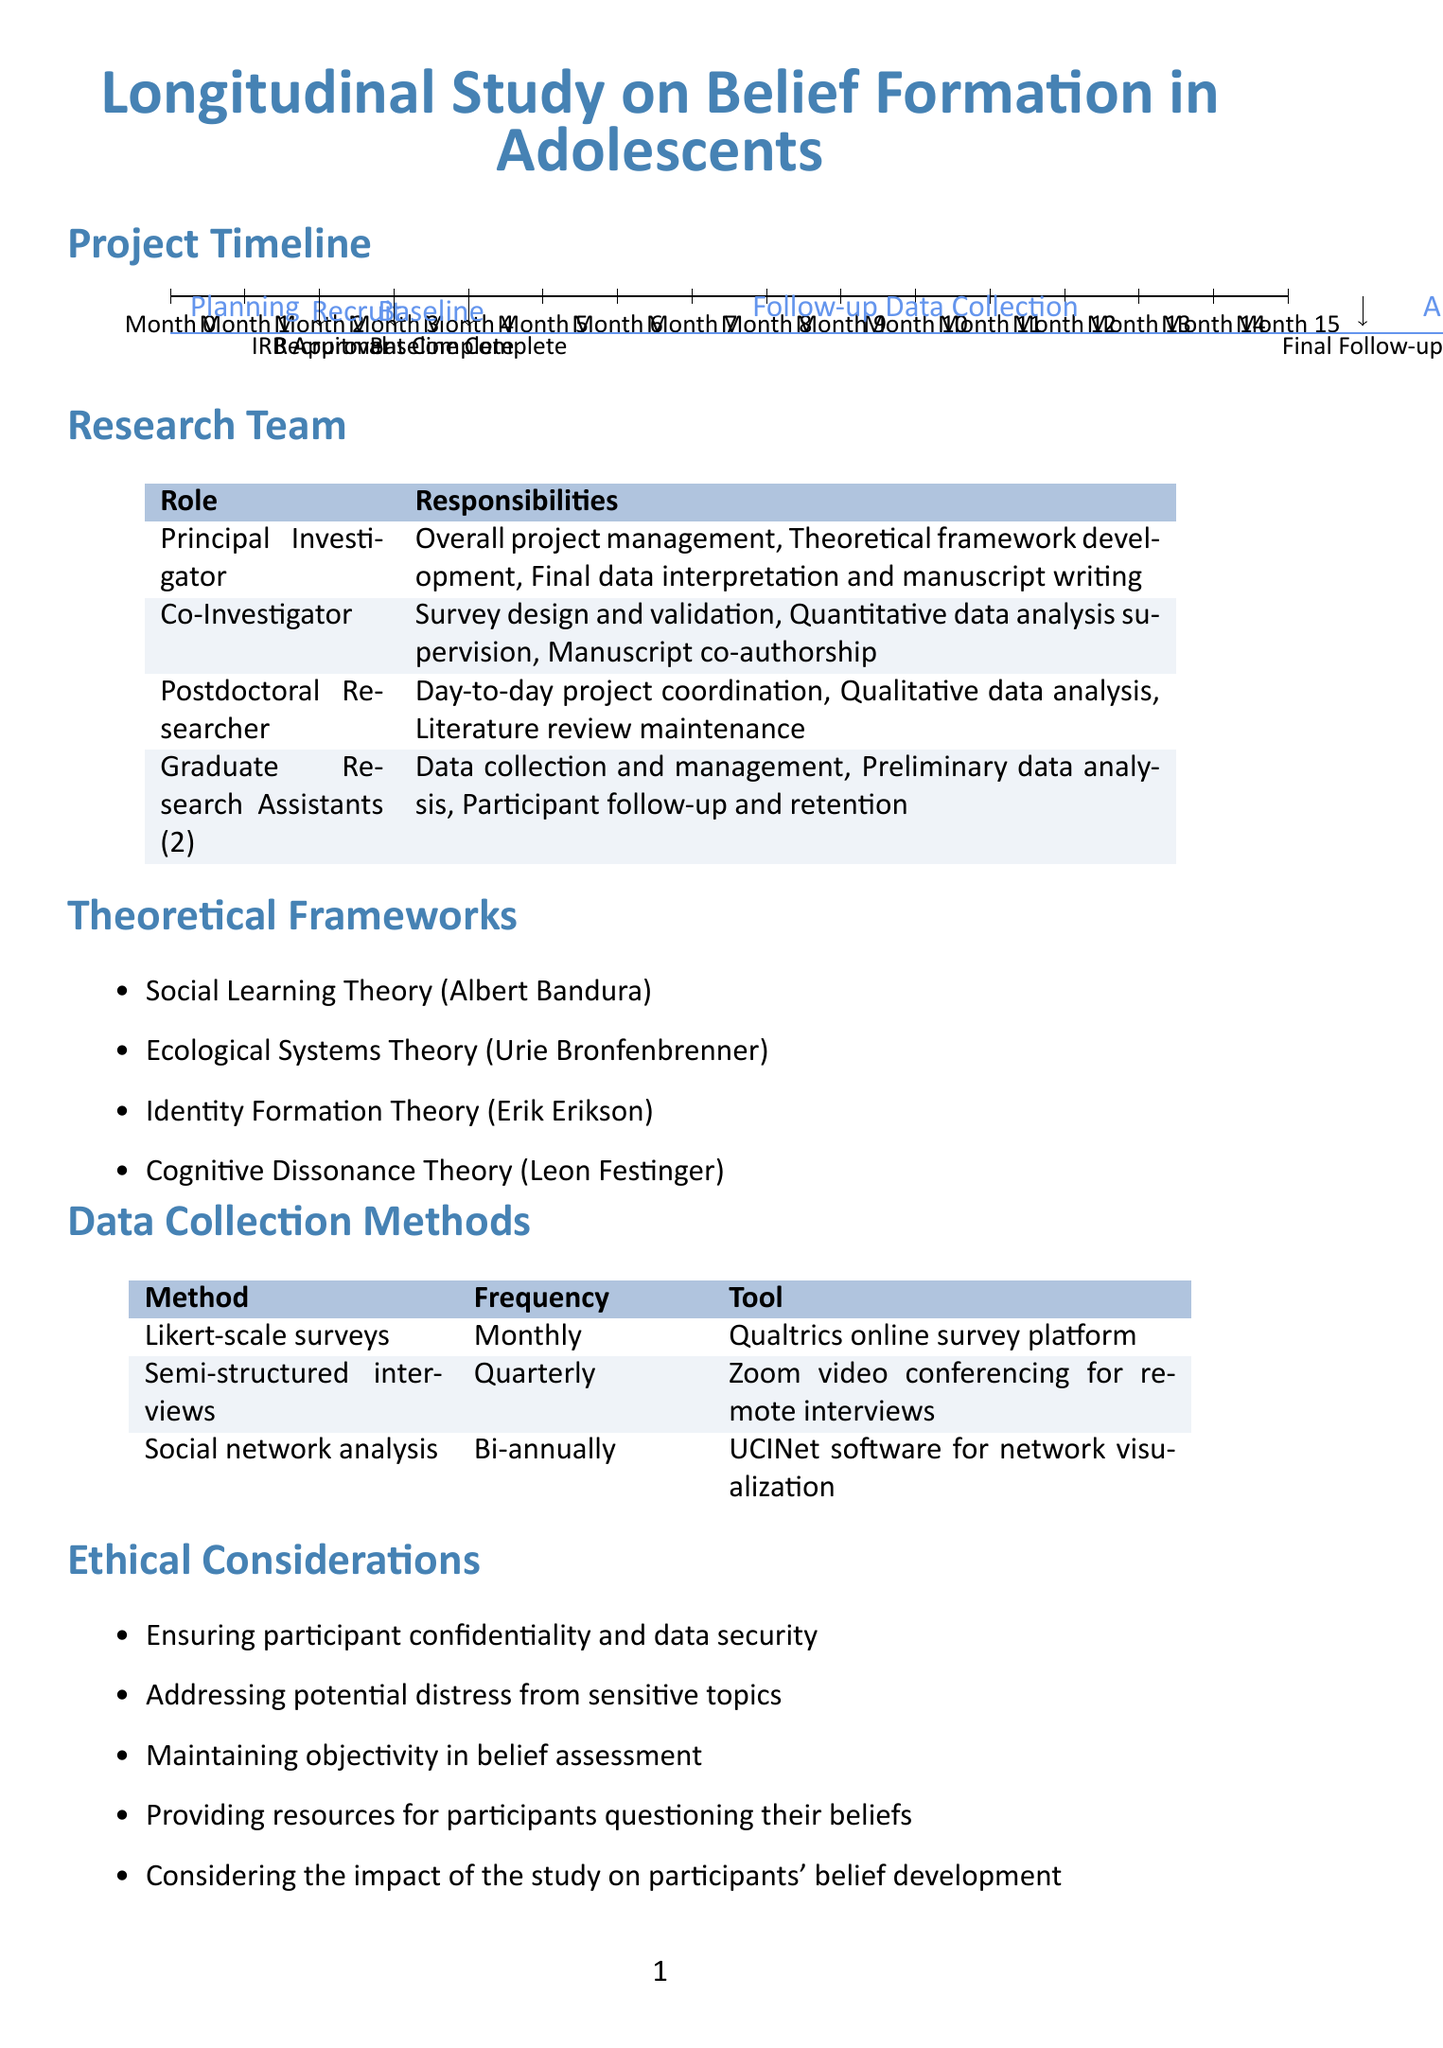What is the duration of the Planning and Preparation phase? The duration of the Planning and Preparation phase is stated in the document as 2 months.
Answer: 2 months When is the IRB Approval milestone targeted to be completed? The target date for IRB Approval is explicitly provided in the document as "End of Month 2".
Answer: End of Month 2 How many Graduate Research Assistants are involved in the study? The document specifies that there are 2 Graduate Research Assistants involved in the study.
Answer: 2 What is the main data collection method used monthly? The document details that Likert-scale surveys are the primary data collection method employed monthly.
Answer: Likert-scale surveys Which theoretical framework originates from Erik Erikson? The document identifies Identity Formation Theory as the theoretical framework associated with Erik Erikson.
Answer: Identity Formation Theory What is the total duration allocated for Data Analysis? The document mentions that the duration allocated for Data Analysis is 3 months.
Answer: 3 months What is one of the ethical considerations regarding participant confidentiality? The ethical considerations include ensuring participant confidentiality and data security, as stated in the document.
Answer: Ensuring participant confidentiality and data security When does the final follow-up data collection conclude? According to the document, the final follow-up data collection is targeted to be completed at "End of Month 16".
Answer: End of Month 16 What software is used for qualitative data analysis? The document indicates that NVivo is the software used for qualitative data analysis.
Answer: NVivo 